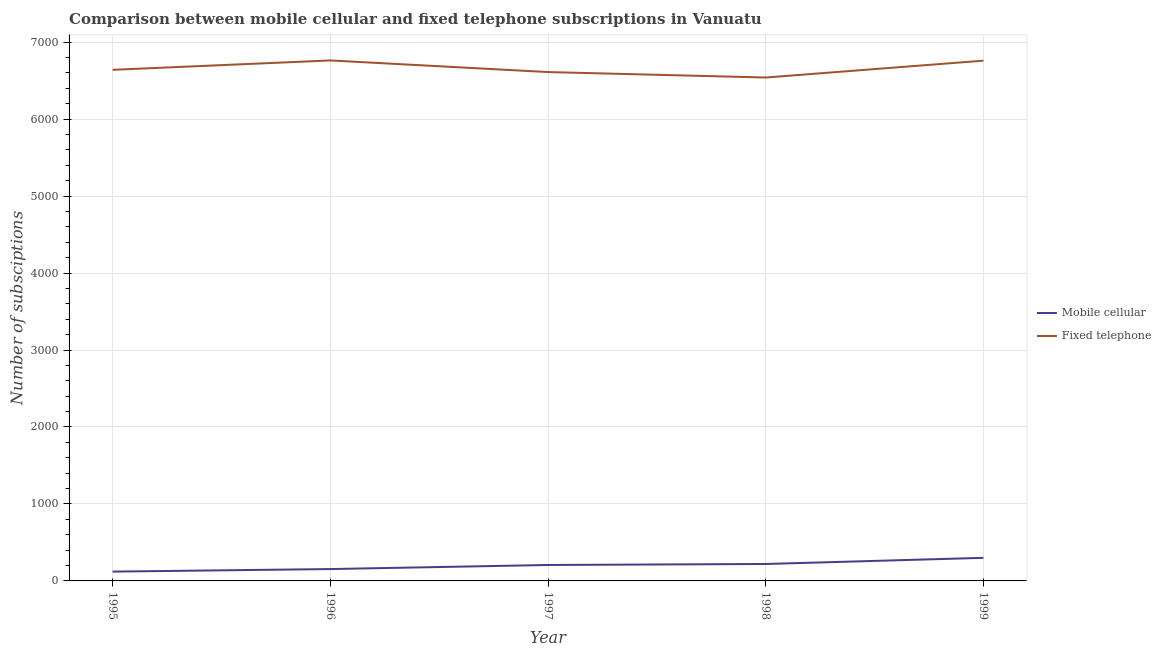How many different coloured lines are there?
Give a very brief answer. 2. What is the number of mobile cellular subscriptions in 1997?
Provide a short and direct response. 207. Across all years, what is the maximum number of fixed telephone subscriptions?
Ensure brevity in your answer.  6762. Across all years, what is the minimum number of mobile cellular subscriptions?
Keep it short and to the point. 121. What is the total number of mobile cellular subscriptions in the graph?
Your answer should be compact. 1002. What is the difference between the number of mobile cellular subscriptions in 1996 and that in 1999?
Keep it short and to the point. -146. What is the difference between the number of mobile cellular subscriptions in 1998 and the number of fixed telephone subscriptions in 1995?
Your answer should be very brief. -6420. What is the average number of fixed telephone subscriptions per year?
Offer a terse response. 6662.4. In the year 1997, what is the difference between the number of fixed telephone subscriptions and number of mobile cellular subscriptions?
Provide a short and direct response. 6404. In how many years, is the number of mobile cellular subscriptions greater than 800?
Ensure brevity in your answer.  0. What is the ratio of the number of fixed telephone subscriptions in 1995 to that in 1998?
Offer a very short reply. 1.02. What is the difference between the highest and the second highest number of mobile cellular subscriptions?
Give a very brief answer. 80. What is the difference between the highest and the lowest number of mobile cellular subscriptions?
Your answer should be compact. 179. Is the sum of the number of mobile cellular subscriptions in 1997 and 1998 greater than the maximum number of fixed telephone subscriptions across all years?
Offer a terse response. No. Is the number of mobile cellular subscriptions strictly greater than the number of fixed telephone subscriptions over the years?
Offer a very short reply. No. Is the number of mobile cellular subscriptions strictly less than the number of fixed telephone subscriptions over the years?
Keep it short and to the point. Yes. How many lines are there?
Keep it short and to the point. 2. How many years are there in the graph?
Your answer should be compact. 5. What is the difference between two consecutive major ticks on the Y-axis?
Keep it short and to the point. 1000. How are the legend labels stacked?
Offer a very short reply. Vertical. What is the title of the graph?
Give a very brief answer. Comparison between mobile cellular and fixed telephone subscriptions in Vanuatu. What is the label or title of the X-axis?
Offer a very short reply. Year. What is the label or title of the Y-axis?
Provide a short and direct response. Number of subsciptions. What is the Number of subsciptions of Mobile cellular in 1995?
Your answer should be very brief. 121. What is the Number of subsciptions in Fixed telephone in 1995?
Offer a terse response. 6640. What is the Number of subsciptions of Mobile cellular in 1996?
Ensure brevity in your answer.  154. What is the Number of subsciptions in Fixed telephone in 1996?
Ensure brevity in your answer.  6762. What is the Number of subsciptions of Mobile cellular in 1997?
Provide a succinct answer. 207. What is the Number of subsciptions in Fixed telephone in 1997?
Make the answer very short. 6611. What is the Number of subsciptions of Mobile cellular in 1998?
Your response must be concise. 220. What is the Number of subsciptions in Fixed telephone in 1998?
Your answer should be compact. 6540. What is the Number of subsciptions of Mobile cellular in 1999?
Offer a very short reply. 300. What is the Number of subsciptions of Fixed telephone in 1999?
Your response must be concise. 6759. Across all years, what is the maximum Number of subsciptions in Mobile cellular?
Your answer should be very brief. 300. Across all years, what is the maximum Number of subsciptions of Fixed telephone?
Make the answer very short. 6762. Across all years, what is the minimum Number of subsciptions of Mobile cellular?
Your answer should be compact. 121. Across all years, what is the minimum Number of subsciptions in Fixed telephone?
Ensure brevity in your answer.  6540. What is the total Number of subsciptions of Mobile cellular in the graph?
Give a very brief answer. 1002. What is the total Number of subsciptions in Fixed telephone in the graph?
Your response must be concise. 3.33e+04. What is the difference between the Number of subsciptions in Mobile cellular in 1995 and that in 1996?
Your answer should be very brief. -33. What is the difference between the Number of subsciptions in Fixed telephone in 1995 and that in 1996?
Provide a short and direct response. -122. What is the difference between the Number of subsciptions in Mobile cellular in 1995 and that in 1997?
Make the answer very short. -86. What is the difference between the Number of subsciptions in Mobile cellular in 1995 and that in 1998?
Provide a succinct answer. -99. What is the difference between the Number of subsciptions in Mobile cellular in 1995 and that in 1999?
Make the answer very short. -179. What is the difference between the Number of subsciptions of Fixed telephone in 1995 and that in 1999?
Give a very brief answer. -119. What is the difference between the Number of subsciptions of Mobile cellular in 1996 and that in 1997?
Keep it short and to the point. -53. What is the difference between the Number of subsciptions of Fixed telephone in 1996 and that in 1997?
Offer a very short reply. 151. What is the difference between the Number of subsciptions in Mobile cellular in 1996 and that in 1998?
Provide a succinct answer. -66. What is the difference between the Number of subsciptions in Fixed telephone in 1996 and that in 1998?
Your answer should be very brief. 222. What is the difference between the Number of subsciptions of Mobile cellular in 1996 and that in 1999?
Give a very brief answer. -146. What is the difference between the Number of subsciptions in Fixed telephone in 1996 and that in 1999?
Provide a succinct answer. 3. What is the difference between the Number of subsciptions of Fixed telephone in 1997 and that in 1998?
Offer a very short reply. 71. What is the difference between the Number of subsciptions of Mobile cellular in 1997 and that in 1999?
Keep it short and to the point. -93. What is the difference between the Number of subsciptions in Fixed telephone in 1997 and that in 1999?
Give a very brief answer. -148. What is the difference between the Number of subsciptions in Mobile cellular in 1998 and that in 1999?
Provide a short and direct response. -80. What is the difference between the Number of subsciptions of Fixed telephone in 1998 and that in 1999?
Your response must be concise. -219. What is the difference between the Number of subsciptions of Mobile cellular in 1995 and the Number of subsciptions of Fixed telephone in 1996?
Your answer should be very brief. -6641. What is the difference between the Number of subsciptions in Mobile cellular in 1995 and the Number of subsciptions in Fixed telephone in 1997?
Provide a succinct answer. -6490. What is the difference between the Number of subsciptions of Mobile cellular in 1995 and the Number of subsciptions of Fixed telephone in 1998?
Your answer should be compact. -6419. What is the difference between the Number of subsciptions in Mobile cellular in 1995 and the Number of subsciptions in Fixed telephone in 1999?
Ensure brevity in your answer.  -6638. What is the difference between the Number of subsciptions in Mobile cellular in 1996 and the Number of subsciptions in Fixed telephone in 1997?
Provide a short and direct response. -6457. What is the difference between the Number of subsciptions of Mobile cellular in 1996 and the Number of subsciptions of Fixed telephone in 1998?
Make the answer very short. -6386. What is the difference between the Number of subsciptions in Mobile cellular in 1996 and the Number of subsciptions in Fixed telephone in 1999?
Your answer should be compact. -6605. What is the difference between the Number of subsciptions in Mobile cellular in 1997 and the Number of subsciptions in Fixed telephone in 1998?
Keep it short and to the point. -6333. What is the difference between the Number of subsciptions of Mobile cellular in 1997 and the Number of subsciptions of Fixed telephone in 1999?
Offer a very short reply. -6552. What is the difference between the Number of subsciptions in Mobile cellular in 1998 and the Number of subsciptions in Fixed telephone in 1999?
Provide a short and direct response. -6539. What is the average Number of subsciptions of Mobile cellular per year?
Give a very brief answer. 200.4. What is the average Number of subsciptions in Fixed telephone per year?
Give a very brief answer. 6662.4. In the year 1995, what is the difference between the Number of subsciptions in Mobile cellular and Number of subsciptions in Fixed telephone?
Keep it short and to the point. -6519. In the year 1996, what is the difference between the Number of subsciptions in Mobile cellular and Number of subsciptions in Fixed telephone?
Give a very brief answer. -6608. In the year 1997, what is the difference between the Number of subsciptions of Mobile cellular and Number of subsciptions of Fixed telephone?
Give a very brief answer. -6404. In the year 1998, what is the difference between the Number of subsciptions of Mobile cellular and Number of subsciptions of Fixed telephone?
Your response must be concise. -6320. In the year 1999, what is the difference between the Number of subsciptions of Mobile cellular and Number of subsciptions of Fixed telephone?
Keep it short and to the point. -6459. What is the ratio of the Number of subsciptions in Mobile cellular in 1995 to that in 1996?
Your answer should be compact. 0.79. What is the ratio of the Number of subsciptions in Fixed telephone in 1995 to that in 1996?
Your answer should be very brief. 0.98. What is the ratio of the Number of subsciptions in Mobile cellular in 1995 to that in 1997?
Give a very brief answer. 0.58. What is the ratio of the Number of subsciptions in Mobile cellular in 1995 to that in 1998?
Offer a very short reply. 0.55. What is the ratio of the Number of subsciptions in Fixed telephone in 1995 to that in 1998?
Provide a short and direct response. 1.02. What is the ratio of the Number of subsciptions of Mobile cellular in 1995 to that in 1999?
Your answer should be compact. 0.4. What is the ratio of the Number of subsciptions of Fixed telephone in 1995 to that in 1999?
Your answer should be very brief. 0.98. What is the ratio of the Number of subsciptions of Mobile cellular in 1996 to that in 1997?
Your answer should be very brief. 0.74. What is the ratio of the Number of subsciptions in Fixed telephone in 1996 to that in 1997?
Your answer should be very brief. 1.02. What is the ratio of the Number of subsciptions in Fixed telephone in 1996 to that in 1998?
Offer a very short reply. 1.03. What is the ratio of the Number of subsciptions in Mobile cellular in 1996 to that in 1999?
Your response must be concise. 0.51. What is the ratio of the Number of subsciptions of Mobile cellular in 1997 to that in 1998?
Make the answer very short. 0.94. What is the ratio of the Number of subsciptions of Fixed telephone in 1997 to that in 1998?
Offer a terse response. 1.01. What is the ratio of the Number of subsciptions of Mobile cellular in 1997 to that in 1999?
Keep it short and to the point. 0.69. What is the ratio of the Number of subsciptions in Fixed telephone in 1997 to that in 1999?
Your answer should be very brief. 0.98. What is the ratio of the Number of subsciptions in Mobile cellular in 1998 to that in 1999?
Provide a succinct answer. 0.73. What is the ratio of the Number of subsciptions in Fixed telephone in 1998 to that in 1999?
Your response must be concise. 0.97. What is the difference between the highest and the second highest Number of subsciptions in Mobile cellular?
Your response must be concise. 80. What is the difference between the highest and the second highest Number of subsciptions in Fixed telephone?
Provide a succinct answer. 3. What is the difference between the highest and the lowest Number of subsciptions in Mobile cellular?
Your response must be concise. 179. What is the difference between the highest and the lowest Number of subsciptions in Fixed telephone?
Your response must be concise. 222. 